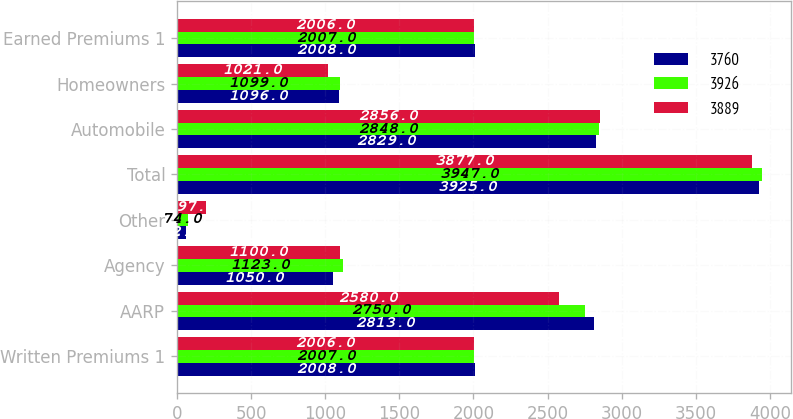<chart> <loc_0><loc_0><loc_500><loc_500><stacked_bar_chart><ecel><fcel>Written Premiums 1<fcel>AARP<fcel>Agency<fcel>Other<fcel>Total<fcel>Automobile<fcel>Homeowners<fcel>Earned Premiums 1<nl><fcel>3760<fcel>2008<fcel>2813<fcel>1050<fcel>62<fcel>3925<fcel>2829<fcel>1096<fcel>2008<nl><fcel>3926<fcel>2007<fcel>2750<fcel>1123<fcel>74<fcel>3947<fcel>2848<fcel>1099<fcel>2007<nl><fcel>3889<fcel>2006<fcel>2580<fcel>1100<fcel>197<fcel>3877<fcel>2856<fcel>1021<fcel>2006<nl></chart> 